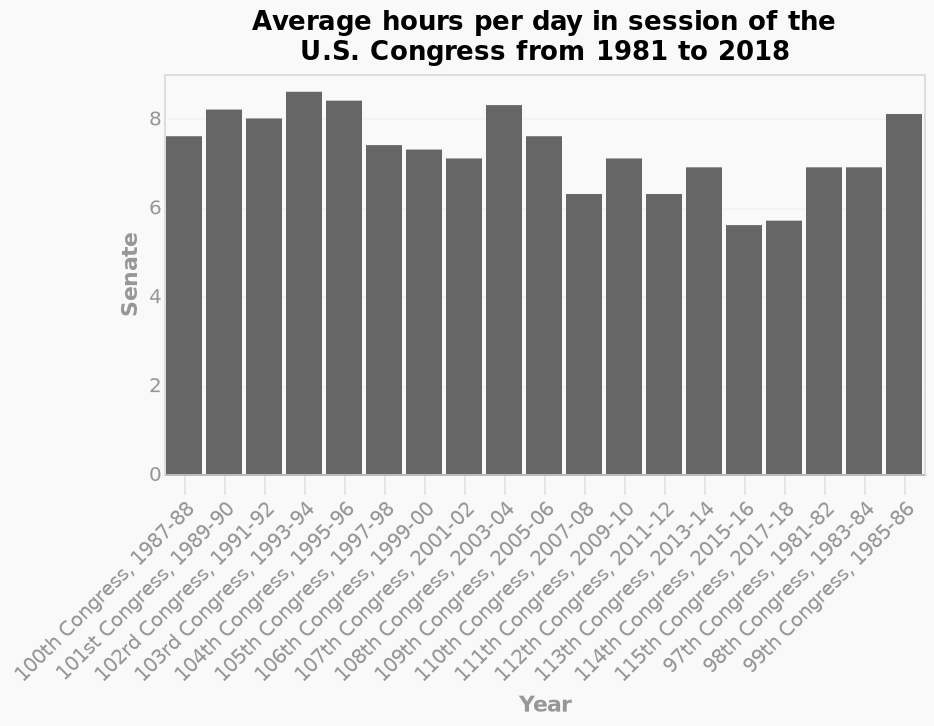<image>
What is the timeframe covered in the bar chart? The bar chart covers the timeframe from 1981 to 2018, displaying the average hours per day in session of the U.S. Congress. What is shown on the y-axis of the chart? The y-axis of the chart represents the Senate. How does the Y-axis of the senate increase over time?  The Y-axis of the senate increases by increments of 2 hours. 